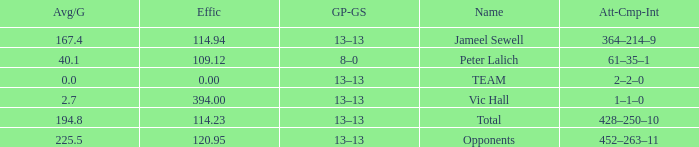Avg/G smaller than 225.5, and a GP-GS of 8–0 has what name? Peter Lalich. 